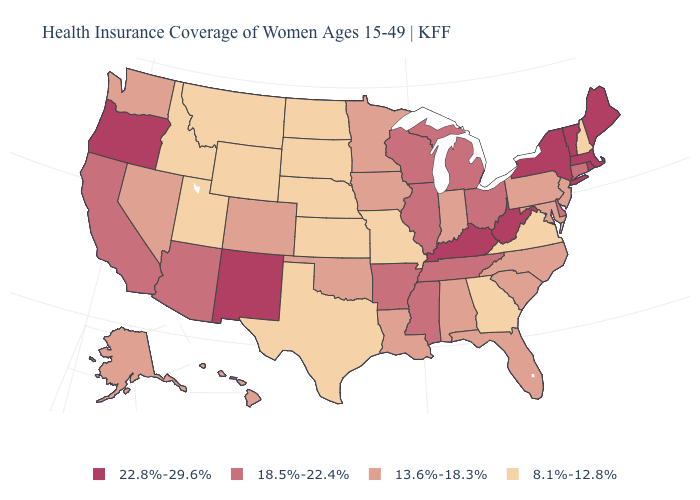Does the first symbol in the legend represent the smallest category?
Give a very brief answer. No. What is the value of Washington?
Concise answer only. 13.6%-18.3%. Does the map have missing data?
Be succinct. No. Does Washington have the highest value in the West?
Write a very short answer. No. What is the lowest value in the USA?
Concise answer only. 8.1%-12.8%. Among the states that border Michigan , which have the highest value?
Answer briefly. Ohio, Wisconsin. Among the states that border Virginia , does Kentucky have the highest value?
Answer briefly. Yes. How many symbols are there in the legend?
Quick response, please. 4. What is the lowest value in states that border Arkansas?
Keep it brief. 8.1%-12.8%. Does New York have the same value as Louisiana?
Concise answer only. No. What is the lowest value in the Northeast?
Keep it brief. 8.1%-12.8%. What is the lowest value in the Northeast?
Concise answer only. 8.1%-12.8%. What is the value of Tennessee?
Concise answer only. 18.5%-22.4%. Name the states that have a value in the range 18.5%-22.4%?
Quick response, please. Arizona, Arkansas, California, Connecticut, Delaware, Illinois, Michigan, Mississippi, Ohio, Tennessee, Wisconsin. Does Wyoming have the lowest value in the USA?
Keep it brief. Yes. 